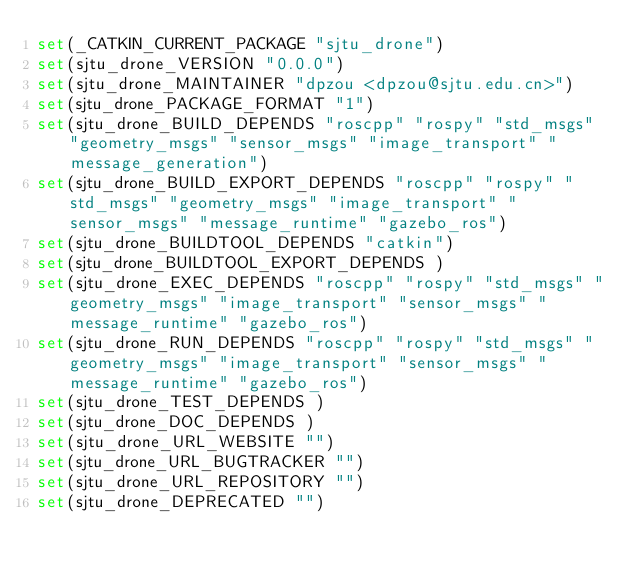<code> <loc_0><loc_0><loc_500><loc_500><_CMake_>set(_CATKIN_CURRENT_PACKAGE "sjtu_drone")
set(sjtu_drone_VERSION "0.0.0")
set(sjtu_drone_MAINTAINER "dpzou <dpzou@sjtu.edu.cn>")
set(sjtu_drone_PACKAGE_FORMAT "1")
set(sjtu_drone_BUILD_DEPENDS "roscpp" "rospy" "std_msgs" "geometry_msgs" "sensor_msgs" "image_transport" "message_generation")
set(sjtu_drone_BUILD_EXPORT_DEPENDS "roscpp" "rospy" "std_msgs" "geometry_msgs" "image_transport" "sensor_msgs" "message_runtime" "gazebo_ros")
set(sjtu_drone_BUILDTOOL_DEPENDS "catkin")
set(sjtu_drone_BUILDTOOL_EXPORT_DEPENDS )
set(sjtu_drone_EXEC_DEPENDS "roscpp" "rospy" "std_msgs" "geometry_msgs" "image_transport" "sensor_msgs" "message_runtime" "gazebo_ros")
set(sjtu_drone_RUN_DEPENDS "roscpp" "rospy" "std_msgs" "geometry_msgs" "image_transport" "sensor_msgs" "message_runtime" "gazebo_ros")
set(sjtu_drone_TEST_DEPENDS )
set(sjtu_drone_DOC_DEPENDS )
set(sjtu_drone_URL_WEBSITE "")
set(sjtu_drone_URL_BUGTRACKER "")
set(sjtu_drone_URL_REPOSITORY "")
set(sjtu_drone_DEPRECATED "")</code> 